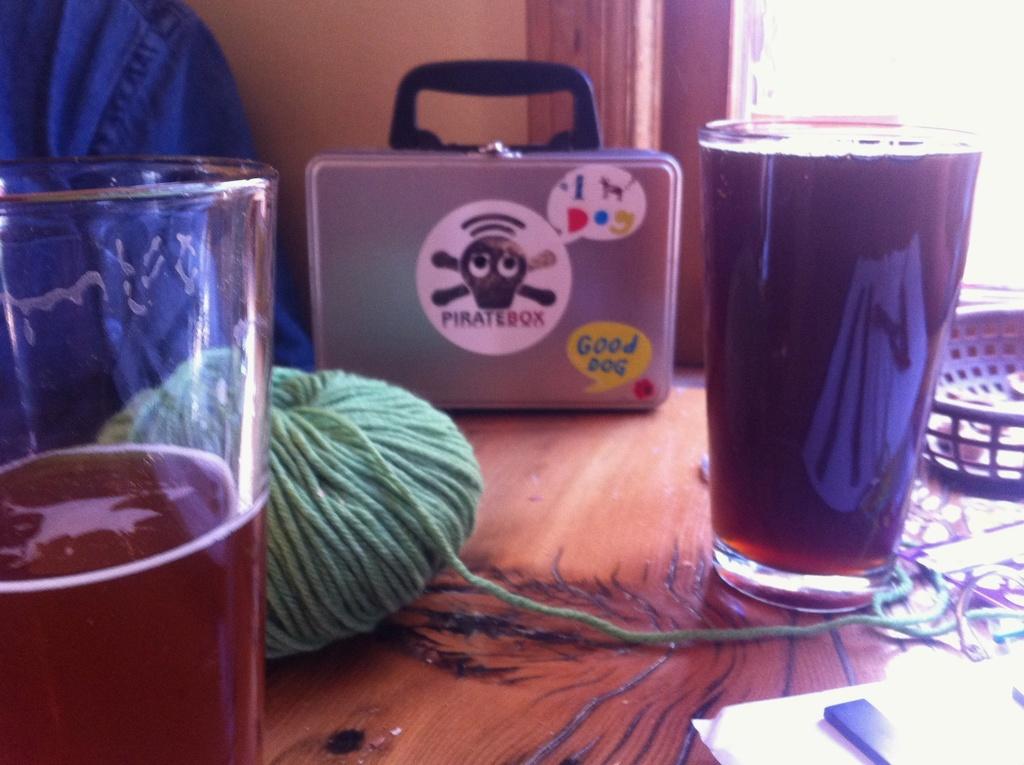What is the speak bubble?
Offer a terse response. Good dog. 